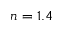Convert formula to latex. <formula><loc_0><loc_0><loc_500><loc_500>n = 1 . 4</formula> 